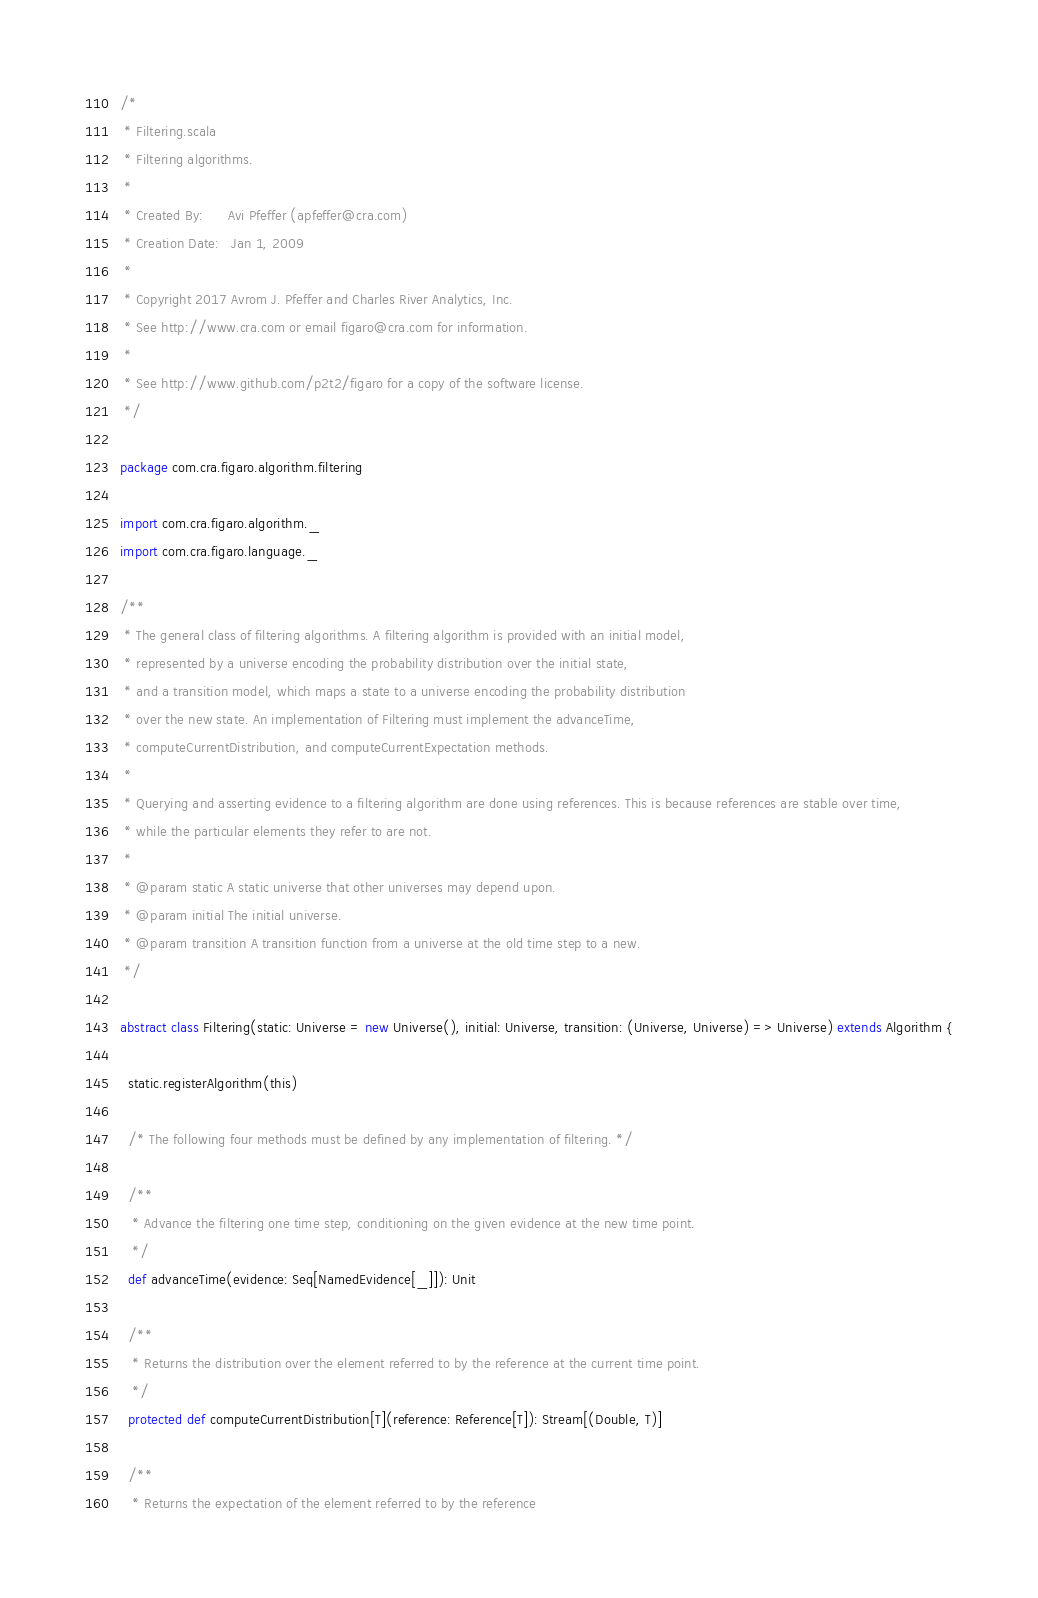Convert code to text. <code><loc_0><loc_0><loc_500><loc_500><_Scala_>/*
 * Filtering.scala
 * Filtering algorithms.
 * 
 * Created By:      Avi Pfeffer (apfeffer@cra.com)
 * Creation Date:   Jan 1, 2009
 * 
 * Copyright 2017 Avrom J. Pfeffer and Charles River Analytics, Inc.
 * See http://www.cra.com or email figaro@cra.com for information.
 * 
 * See http://www.github.com/p2t2/figaro for a copy of the software license.
 */

package com.cra.figaro.algorithm.filtering

import com.cra.figaro.algorithm._
import com.cra.figaro.language._

/**
 * The general class of filtering algorithms. A filtering algorithm is provided with an initial model,
 * represented by a universe encoding the probability distribution over the initial state,
 * and a transition model, which maps a state to a universe encoding the probability distribution
 * over the new state. An implementation of Filtering must implement the advanceTime,
 * computeCurrentDistribution, and computeCurrentExpectation methods.
 * 
 * Querying and asserting evidence to a filtering algorithm are done using references. This is because references are stable over time,
 * while the particular elements they refer to are not.
 * 
 * @param static A static universe that other universes may depend upon.
 * @param initial The initial universe.
 * @param transition A transition function from a universe at the old time step to a new.
 */

abstract class Filtering(static: Universe = new Universe(), initial: Universe, transition: (Universe, Universe) => Universe) extends Algorithm {

  static.registerAlgorithm(this)

  /* The following four methods must be defined by any implementation of filtering. */

  /**
   * Advance the filtering one time step, conditioning on the given evidence at the new time point.
   */
  def advanceTime(evidence: Seq[NamedEvidence[_]]): Unit

  /**
   * Returns the distribution over the element referred to by the reference at the current time point.
   */
  protected def computeCurrentDistribution[T](reference: Reference[T]): Stream[(Double, T)]

  /**
   * Returns the expectation of the element referred to by the reference</code> 